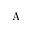Convert formula to latex. <formula><loc_0><loc_0><loc_500><loc_500>A</formula> 